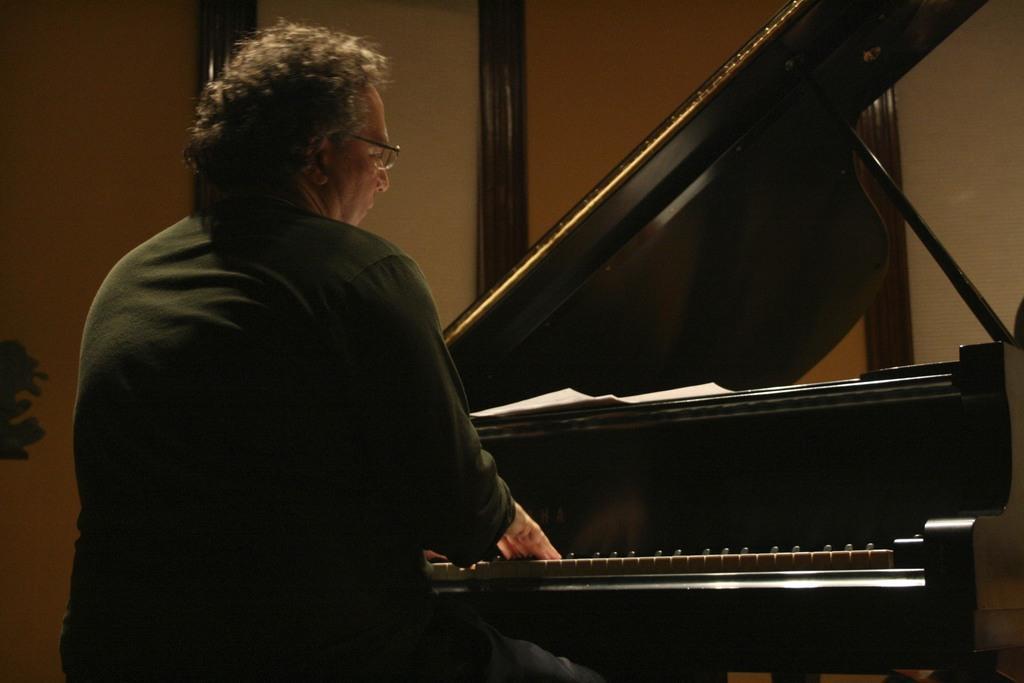Please provide a concise description of this image. In the left, a person is sitting on the chair and playing a piano, who is wearing a specs. The background light brown in color. In the left middle, a house plant is visible. This image is taken inside a room. 